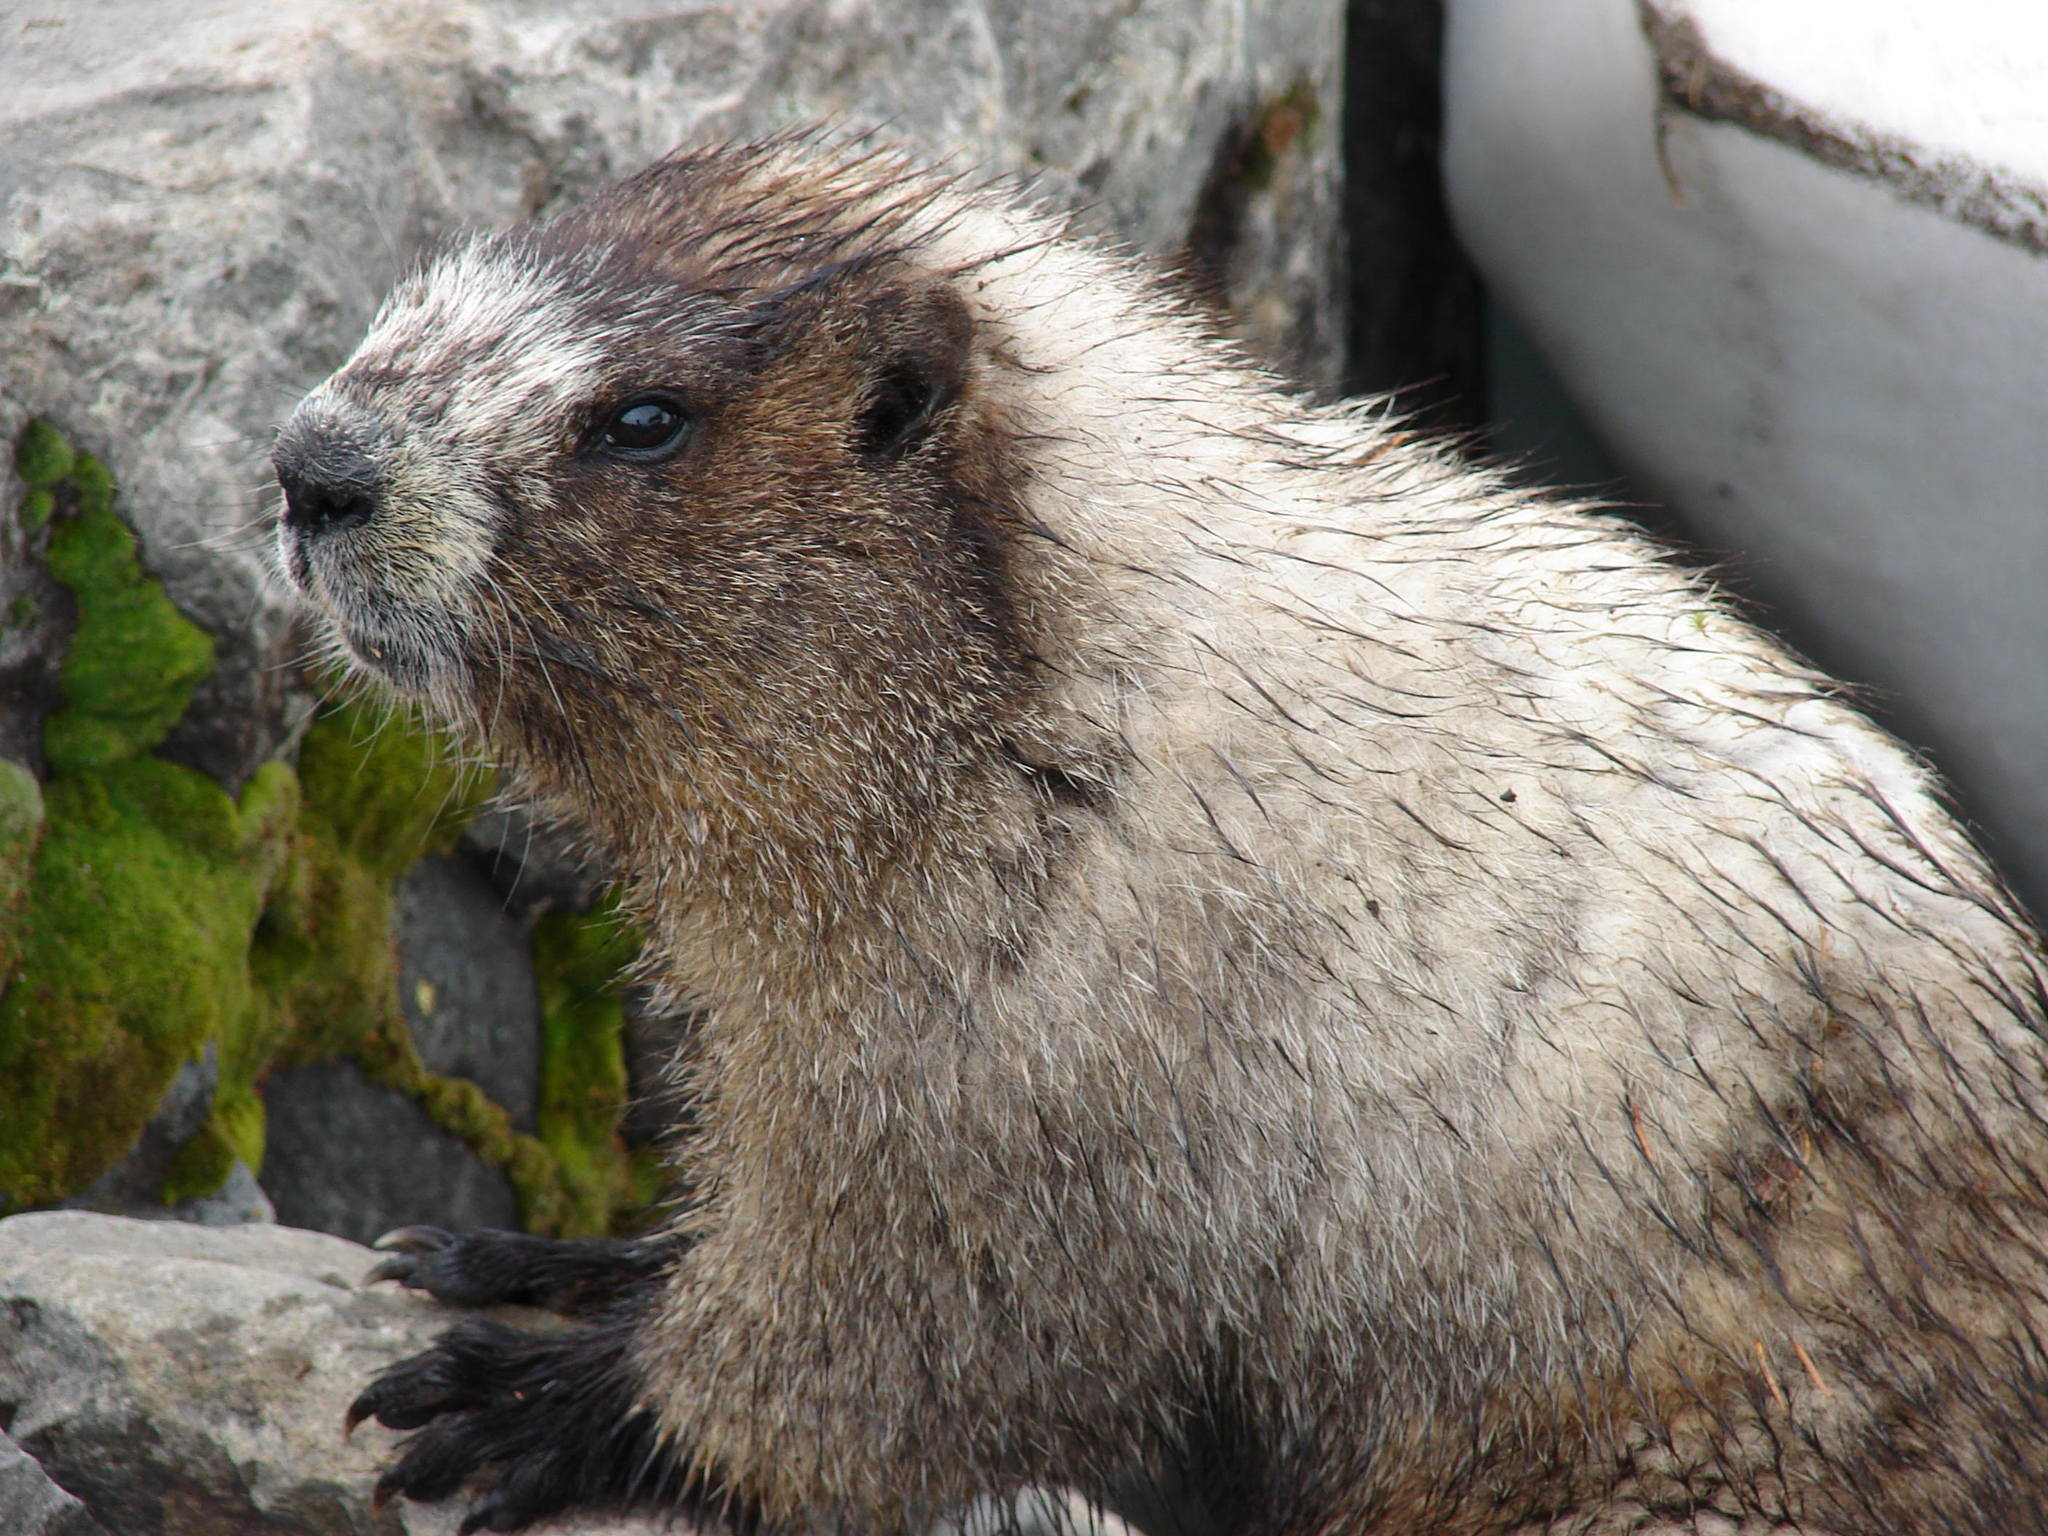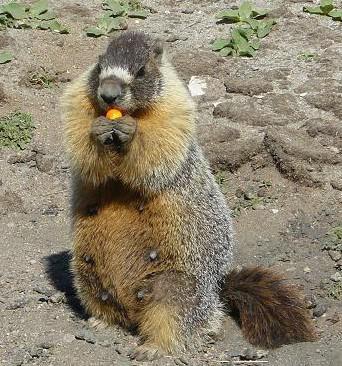The first image is the image on the left, the second image is the image on the right. Evaluate the accuracy of this statement regarding the images: "One image shows a rodent-type animal standing upright with front paws clasped together.". Is it true? Answer yes or no. Yes. 